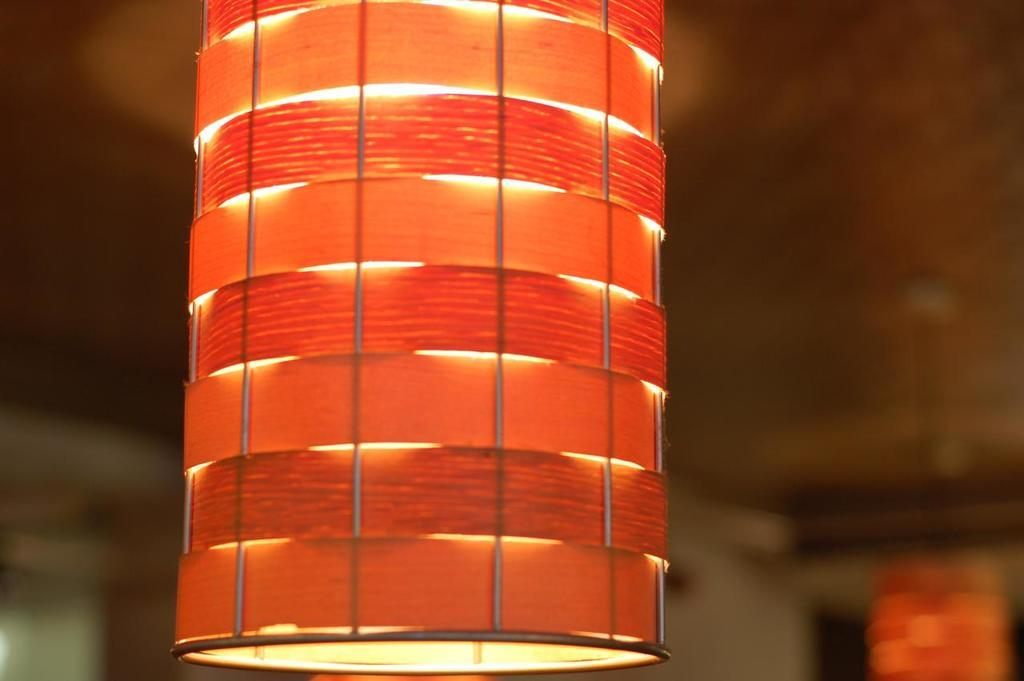What type of lighting is present in the image? There are lamps hanging from the ceiling in the image. How many deer can be seen grazing in the image? There are no deer present in the image; it only features lamps hanging from the ceiling. What type of air is visible in the image? There is no specific type of air visible in the image; it simply shows lamps hanging from the ceiling. 